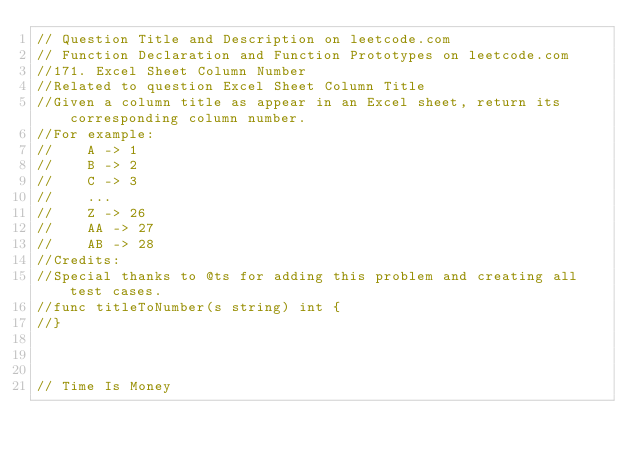<code> <loc_0><loc_0><loc_500><loc_500><_Go_>// Question Title and Description on leetcode.com
// Function Declaration and Function Prototypes on leetcode.com
//171. Excel Sheet Column Number
//Related to question Excel Sheet Column Title
//Given a column title as appear in an Excel sheet, return its corresponding column number.
//For example:
//    A -> 1
//    B -> 2
//    C -> 3
//    ...
//    Z -> 26
//    AA -> 27
//    AB -> 28 
//Credits:
//Special thanks to @ts for adding this problem and creating all test cases.
//func titleToNumber(s string) int {
//}



// Time Is Money</code> 